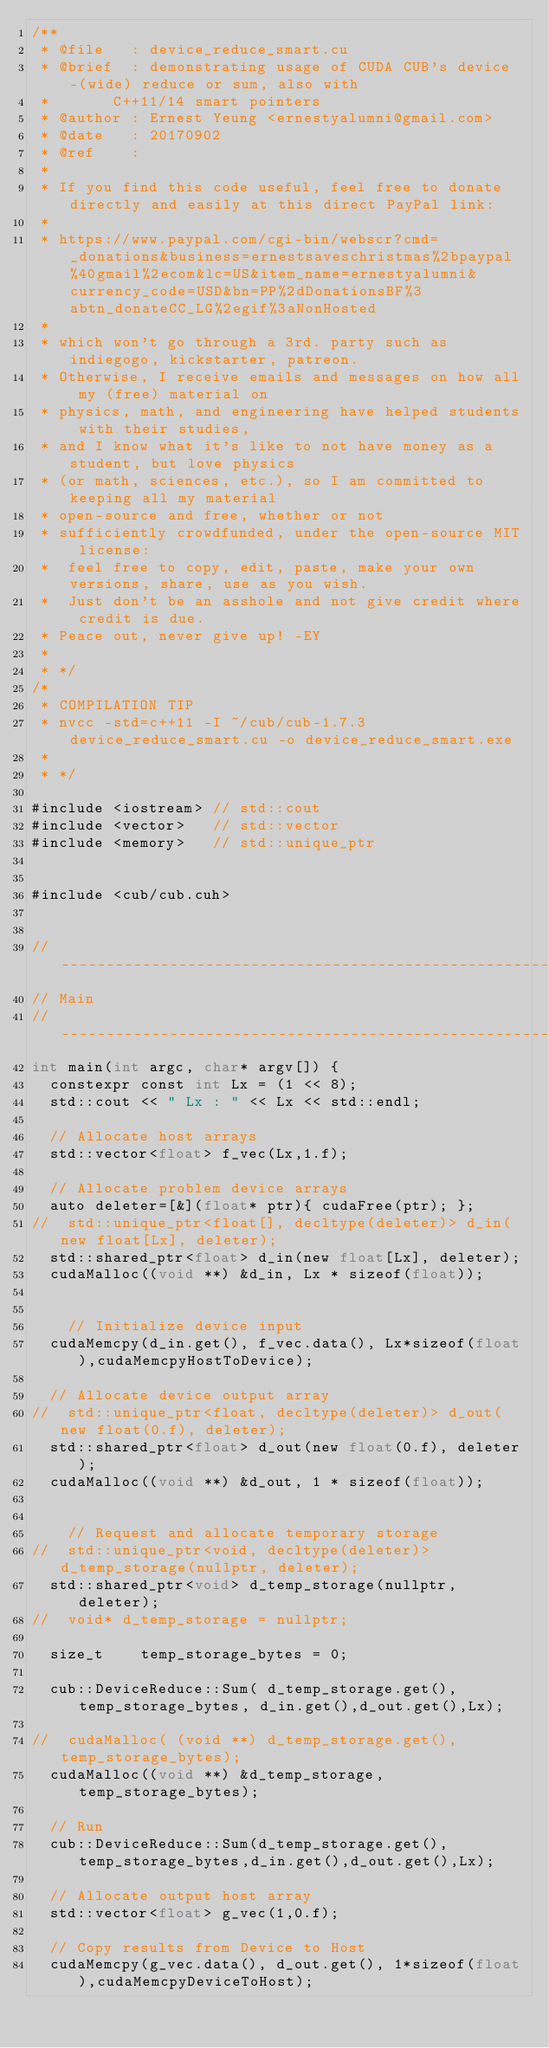<code> <loc_0><loc_0><loc_500><loc_500><_Cuda_>/**
 * @file   : device_reduce_smart.cu
 * @brief  : demonstrating usage of CUDA CUB's device-(wide) reduce or sum, also with 
 * 			 C++11/14 smart pointers
 * @author : Ernest Yeung <ernestyalumni@gmail.com>
 * @date   : 20170902  
 * @ref    :  
 * 
 * If you find this code useful, feel free to donate directly and easily at this direct PayPal link: 
 * 
 * https://www.paypal.com/cgi-bin/webscr?cmd=_donations&business=ernestsaveschristmas%2bpaypal%40gmail%2ecom&lc=US&item_name=ernestyalumni&currency_code=USD&bn=PP%2dDonationsBF%3abtn_donateCC_LG%2egif%3aNonHosted 
 * 
 * which won't go through a 3rd. party such as indiegogo, kickstarter, patreon.  
 * Otherwise, I receive emails and messages on how all my (free) material on 
 * physics, math, and engineering have helped students with their studies, 
 * and I know what it's like to not have money as a student, but love physics 
 * (or math, sciences, etc.), so I am committed to keeping all my material 
 * open-source and free, whether or not 
 * sufficiently crowdfunded, under the open-source MIT license: 
 * 	feel free to copy, edit, paste, make your own versions, share, use as you wish.  
 *  Just don't be an asshole and not give credit where credit is due.  
 * Peace out, never give up! -EY
 * 
 * */
/* 
 * COMPILATION TIP
 * nvcc -std=c++11 -I ~/cub/cub-1.7.3 device_reduce_smart.cu -o device_reduce_smart.exe
 * 
 * */

#include <iostream>	// std::cout
#include <vector> 	// std::vector
#include <memory> 	// std::unique_ptr


#include <cub/cub.cuh>


//---------------------------------------------------------------------
// Main
//---------------------------------------------------------------------
int main(int argc, char* argv[]) {
	constexpr const int Lx = (1 << 8);
	std::cout << " Lx : " << Lx << std::endl;

	// Allocate host arrays
	std::vector<float> f_vec(Lx,1.f);
	
	// Allocate problem device arrays
	auto deleter=[&](float* ptr){ cudaFree(ptr); };
//	std::unique_ptr<float[], decltype(deleter)> d_in(new float[Lx], deleter);
	std::shared_ptr<float> d_in(new float[Lx], deleter);
	cudaMalloc((void **) &d_in, Lx * sizeof(float));


    // Initialize device input
	cudaMemcpy(d_in.get(), f_vec.data(), Lx*sizeof(float),cudaMemcpyHostToDevice);

	// Allocate device output array
//	std::unique_ptr<float, decltype(deleter)> d_out(new float(0.f), deleter);
	std::shared_ptr<float> d_out(new float(0.f), deleter);
	cudaMalloc((void **) &d_out, 1 * sizeof(float));


    // Request and allocate temporary storage
//	std::unique_ptr<void, decltype(deleter)> d_temp_storage(nullptr, deleter);
	std::shared_ptr<void> d_temp_storage(nullptr, deleter);
//	void* d_temp_storage = nullptr;
	
	size_t 		temp_storage_bytes = 0;

	cub::DeviceReduce::Sum( d_temp_storage.get(), temp_storage_bytes, d_in.get(),d_out.get(),Lx);

//	cudaMalloc( (void **) d_temp_storage.get(), temp_storage_bytes);
	cudaMalloc((void **) &d_temp_storage, temp_storage_bytes);
	
	// Run
	cub::DeviceReduce::Sum(d_temp_storage.get(),temp_storage_bytes,d_in.get(),d_out.get(),Lx);

	// Allocate output host array
	std::vector<float> g_vec(1,0.f);
	
	// Copy results from Device to Host
	cudaMemcpy(g_vec.data(), d_out.get(), 1*sizeof(float),cudaMemcpyDeviceToHost);
</code> 